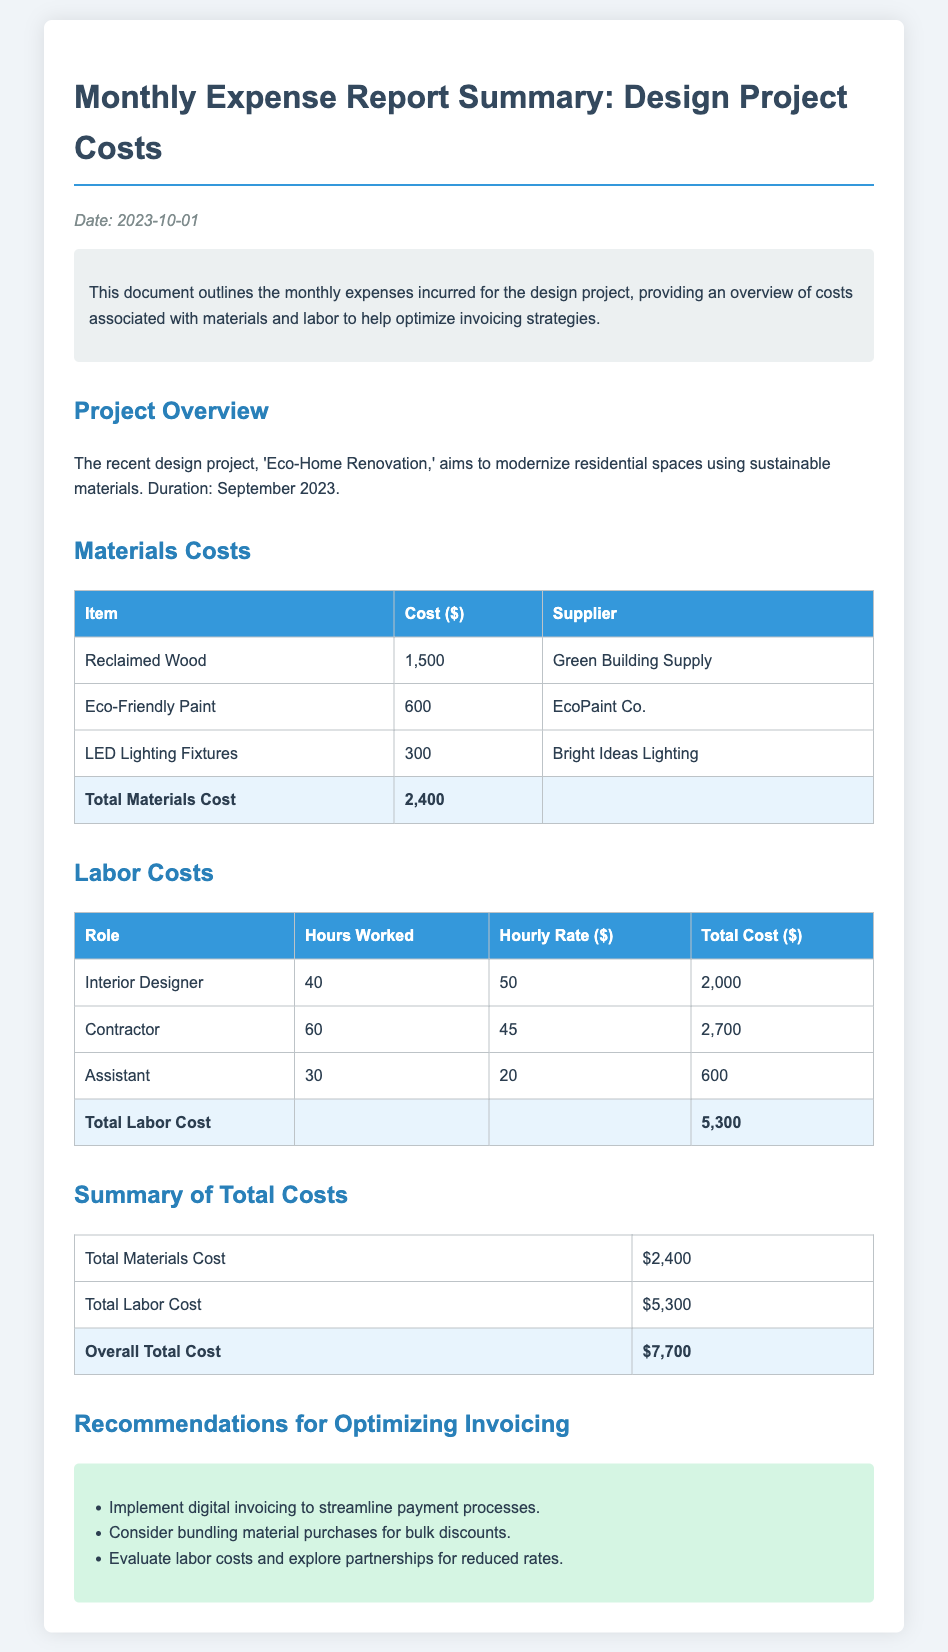What is the date of the report? The date of the report is mentioned at the top of the document as "2023-10-01."
Answer: 2023-10-01 What is the total cost of materials? The total cost of materials is provided in the materials cost section as "2,400."
Answer: 2,400 Who was the supplier for Eco-Friendly Paint? The supplier for Eco-Friendly Paint is specified as "EcoPaint Co." in the materials table.
Answer: EcoPaint Co What is the hourly rate for the Contractor? The hourly rate for the Contractor is listed as "45" in the labor costs section.
Answer: 45 What is the overall total cost of the project? The overall total cost is the sum of total materials cost and total labor cost, which is "7,700."
Answer: 7,700 How many hours did the Assistant work? The number of hours the Assistant worked is mentioned in the labor costs section as "30."
Answer: 30 What recommendation involves digital invoicing? The document recommends implementing digital invoicing to streamline payment processes.
Answer: Digital Invoicing What type of project is summarized in the report? The project summarized in the report is called "Eco-Home Renovation."
Answer: Eco-Home Renovation What is one way to reduce labor costs according to the recommendations? One recommendation to reduce labor costs is to explore partnerships for reduced rates.
Answer: Partnerships 